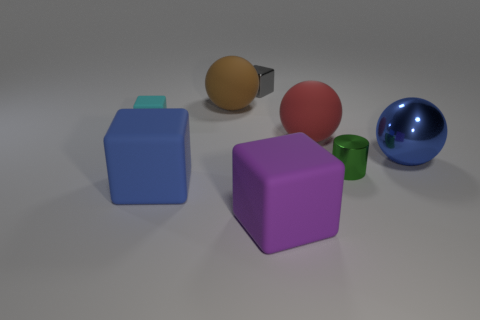How many other objects are there of the same color as the small rubber cube?
Your answer should be very brief. 0. Do the blue thing that is behind the small green cylinder and the blue object left of the shiny cylinder have the same size?
Your answer should be very brief. Yes. The large matte thing that is behind the red thing is what color?
Give a very brief answer. Brown. Is the number of small cubes that are in front of the gray metallic object less than the number of big spheres?
Ensure brevity in your answer.  Yes. Are the large brown ball and the red thing made of the same material?
Make the answer very short. Yes. What is the size of the gray thing that is the same shape as the purple object?
Keep it short and to the point. Small. What number of things are either matte blocks that are on the right side of the cyan cube or matte things in front of the green object?
Provide a short and direct response. 2. Is the number of blue rubber cubes less than the number of small blue matte spheres?
Offer a terse response. No. Do the green metallic cylinder and the sphere in front of the red rubber thing have the same size?
Provide a succinct answer. No. What number of matte objects are either cyan objects or brown objects?
Provide a short and direct response. 2. 